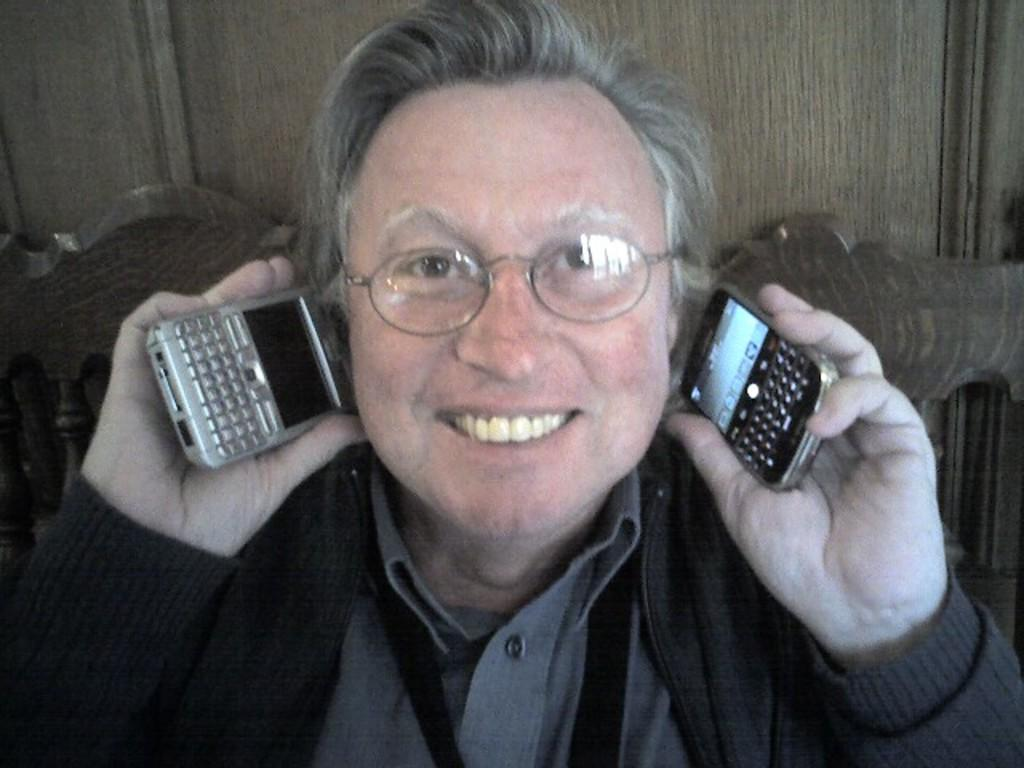Who is present in the image? There is a man in the image. What is the man wearing? The man is wearing a black coat. What is the man holding in the image? The man is holding two mobiles. What can be seen in the background of the image? There is a chair and a wall in the background of the image. What type of volleyball is the man playing in the image? There is no volleyball present in the image, and the man is not playing any sport. 